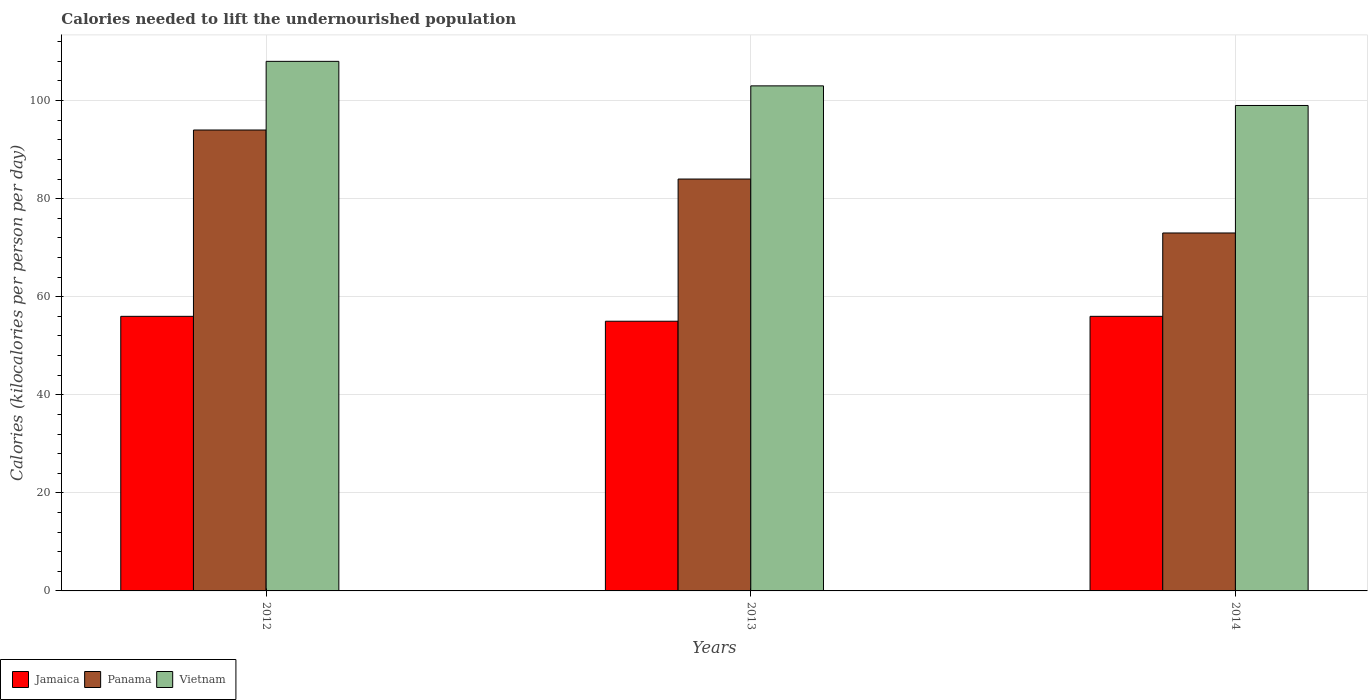How many groups of bars are there?
Make the answer very short. 3. Are the number of bars per tick equal to the number of legend labels?
Keep it short and to the point. Yes. How many bars are there on the 3rd tick from the right?
Offer a very short reply. 3. In how many cases, is the number of bars for a given year not equal to the number of legend labels?
Ensure brevity in your answer.  0. What is the total calories needed to lift the undernourished population in Jamaica in 2013?
Offer a very short reply. 55. Across all years, what is the maximum total calories needed to lift the undernourished population in Panama?
Your answer should be compact. 94. Across all years, what is the minimum total calories needed to lift the undernourished population in Vietnam?
Offer a very short reply. 99. In which year was the total calories needed to lift the undernourished population in Jamaica maximum?
Offer a terse response. 2012. In which year was the total calories needed to lift the undernourished population in Jamaica minimum?
Offer a very short reply. 2013. What is the total total calories needed to lift the undernourished population in Jamaica in the graph?
Provide a succinct answer. 167. What is the difference between the total calories needed to lift the undernourished population in Jamaica in 2012 and that in 2014?
Your answer should be compact. 0. What is the difference between the total calories needed to lift the undernourished population in Panama in 2012 and the total calories needed to lift the undernourished population in Vietnam in 2013?
Make the answer very short. -9. What is the average total calories needed to lift the undernourished population in Vietnam per year?
Your answer should be very brief. 103.33. In the year 2012, what is the difference between the total calories needed to lift the undernourished population in Panama and total calories needed to lift the undernourished population in Vietnam?
Make the answer very short. -14. In how many years, is the total calories needed to lift the undernourished population in Jamaica greater than 104 kilocalories?
Ensure brevity in your answer.  0. What is the ratio of the total calories needed to lift the undernourished population in Panama in 2013 to that in 2014?
Offer a very short reply. 1.15. Is the total calories needed to lift the undernourished population in Vietnam in 2013 less than that in 2014?
Ensure brevity in your answer.  No. What is the difference between the highest and the lowest total calories needed to lift the undernourished population in Panama?
Give a very brief answer. 21. What does the 3rd bar from the left in 2012 represents?
Your answer should be very brief. Vietnam. What does the 3rd bar from the right in 2012 represents?
Make the answer very short. Jamaica. Are all the bars in the graph horizontal?
Provide a succinct answer. No. How many years are there in the graph?
Give a very brief answer. 3. What is the difference between two consecutive major ticks on the Y-axis?
Give a very brief answer. 20. Does the graph contain any zero values?
Your answer should be very brief. No. Where does the legend appear in the graph?
Make the answer very short. Bottom left. How many legend labels are there?
Provide a short and direct response. 3. How are the legend labels stacked?
Your answer should be compact. Horizontal. What is the title of the graph?
Make the answer very short. Calories needed to lift the undernourished population. What is the label or title of the X-axis?
Offer a very short reply. Years. What is the label or title of the Y-axis?
Provide a succinct answer. Calories (kilocalories per person per day). What is the Calories (kilocalories per person per day) of Panama in 2012?
Ensure brevity in your answer.  94. What is the Calories (kilocalories per person per day) in Vietnam in 2012?
Offer a very short reply. 108. What is the Calories (kilocalories per person per day) of Jamaica in 2013?
Your answer should be compact. 55. What is the Calories (kilocalories per person per day) in Vietnam in 2013?
Offer a terse response. 103. What is the Calories (kilocalories per person per day) in Panama in 2014?
Keep it short and to the point. 73. What is the Calories (kilocalories per person per day) in Vietnam in 2014?
Provide a succinct answer. 99. Across all years, what is the maximum Calories (kilocalories per person per day) in Panama?
Give a very brief answer. 94. Across all years, what is the maximum Calories (kilocalories per person per day) in Vietnam?
Make the answer very short. 108. Across all years, what is the minimum Calories (kilocalories per person per day) in Panama?
Offer a very short reply. 73. Across all years, what is the minimum Calories (kilocalories per person per day) in Vietnam?
Your answer should be very brief. 99. What is the total Calories (kilocalories per person per day) in Jamaica in the graph?
Your response must be concise. 167. What is the total Calories (kilocalories per person per day) of Panama in the graph?
Your answer should be very brief. 251. What is the total Calories (kilocalories per person per day) in Vietnam in the graph?
Your response must be concise. 310. What is the difference between the Calories (kilocalories per person per day) of Jamaica in 2012 and that in 2013?
Ensure brevity in your answer.  1. What is the difference between the Calories (kilocalories per person per day) in Panama in 2012 and that in 2013?
Provide a short and direct response. 10. What is the difference between the Calories (kilocalories per person per day) of Jamaica in 2012 and that in 2014?
Ensure brevity in your answer.  0. What is the difference between the Calories (kilocalories per person per day) of Panama in 2012 and that in 2014?
Your response must be concise. 21. What is the difference between the Calories (kilocalories per person per day) of Jamaica in 2013 and that in 2014?
Offer a terse response. -1. What is the difference between the Calories (kilocalories per person per day) in Panama in 2013 and that in 2014?
Make the answer very short. 11. What is the difference between the Calories (kilocalories per person per day) in Vietnam in 2013 and that in 2014?
Make the answer very short. 4. What is the difference between the Calories (kilocalories per person per day) in Jamaica in 2012 and the Calories (kilocalories per person per day) in Panama in 2013?
Keep it short and to the point. -28. What is the difference between the Calories (kilocalories per person per day) in Jamaica in 2012 and the Calories (kilocalories per person per day) in Vietnam in 2013?
Your answer should be very brief. -47. What is the difference between the Calories (kilocalories per person per day) in Panama in 2012 and the Calories (kilocalories per person per day) in Vietnam in 2013?
Provide a succinct answer. -9. What is the difference between the Calories (kilocalories per person per day) in Jamaica in 2012 and the Calories (kilocalories per person per day) in Vietnam in 2014?
Give a very brief answer. -43. What is the difference between the Calories (kilocalories per person per day) in Panama in 2012 and the Calories (kilocalories per person per day) in Vietnam in 2014?
Ensure brevity in your answer.  -5. What is the difference between the Calories (kilocalories per person per day) in Jamaica in 2013 and the Calories (kilocalories per person per day) in Vietnam in 2014?
Provide a succinct answer. -44. What is the average Calories (kilocalories per person per day) of Jamaica per year?
Make the answer very short. 55.67. What is the average Calories (kilocalories per person per day) in Panama per year?
Keep it short and to the point. 83.67. What is the average Calories (kilocalories per person per day) of Vietnam per year?
Your answer should be compact. 103.33. In the year 2012, what is the difference between the Calories (kilocalories per person per day) in Jamaica and Calories (kilocalories per person per day) in Panama?
Provide a short and direct response. -38. In the year 2012, what is the difference between the Calories (kilocalories per person per day) in Jamaica and Calories (kilocalories per person per day) in Vietnam?
Offer a terse response. -52. In the year 2012, what is the difference between the Calories (kilocalories per person per day) of Panama and Calories (kilocalories per person per day) of Vietnam?
Offer a terse response. -14. In the year 2013, what is the difference between the Calories (kilocalories per person per day) in Jamaica and Calories (kilocalories per person per day) in Vietnam?
Give a very brief answer. -48. In the year 2013, what is the difference between the Calories (kilocalories per person per day) in Panama and Calories (kilocalories per person per day) in Vietnam?
Give a very brief answer. -19. In the year 2014, what is the difference between the Calories (kilocalories per person per day) of Jamaica and Calories (kilocalories per person per day) of Vietnam?
Keep it short and to the point. -43. What is the ratio of the Calories (kilocalories per person per day) of Jamaica in 2012 to that in 2013?
Your response must be concise. 1.02. What is the ratio of the Calories (kilocalories per person per day) in Panama in 2012 to that in 2013?
Make the answer very short. 1.12. What is the ratio of the Calories (kilocalories per person per day) in Vietnam in 2012 to that in 2013?
Offer a terse response. 1.05. What is the ratio of the Calories (kilocalories per person per day) in Panama in 2012 to that in 2014?
Offer a terse response. 1.29. What is the ratio of the Calories (kilocalories per person per day) in Jamaica in 2013 to that in 2014?
Keep it short and to the point. 0.98. What is the ratio of the Calories (kilocalories per person per day) of Panama in 2013 to that in 2014?
Offer a terse response. 1.15. What is the ratio of the Calories (kilocalories per person per day) of Vietnam in 2013 to that in 2014?
Your answer should be very brief. 1.04. What is the difference between the highest and the second highest Calories (kilocalories per person per day) of Panama?
Your answer should be compact. 10. What is the difference between the highest and the lowest Calories (kilocalories per person per day) in Panama?
Keep it short and to the point. 21. 